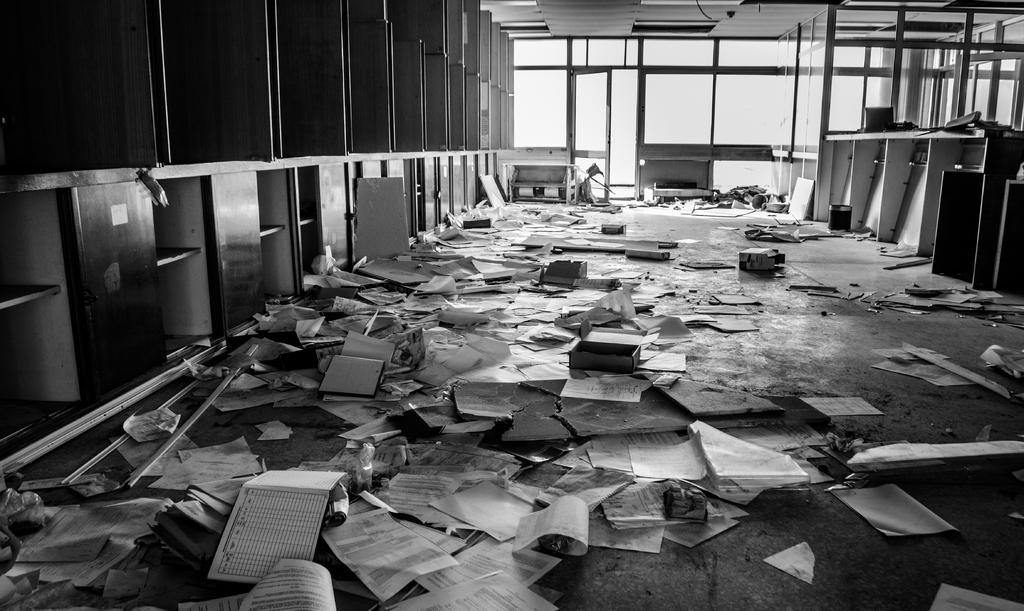What type of items can be seen on the floor in the image? There are objects on the floor in the image. What type of items can be seen on the shelves in the image? There are books in the image. What type of items can be seen on the cupboards in the image? There are papers in the image. What type of windows are present in the image? There are glass windows in the image. What type of door is present in the image? There is a door in the image. How many writers are visible in the image? There is no writer present in the image. What type of body is visible in the image? There is no body present in the image. 